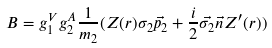Convert formula to latex. <formula><loc_0><loc_0><loc_500><loc_500>B = g ^ { V } _ { 1 } g ^ { A } _ { 2 } \frac { 1 } { m _ { 2 } } ( Z ( r ) \sigma _ { 2 } \vec { p _ { 2 } } + \frac { i } { 2 } \vec { \sigma _ { 2 } } \vec { n } Z ^ { \prime } ( r ) )</formula> 